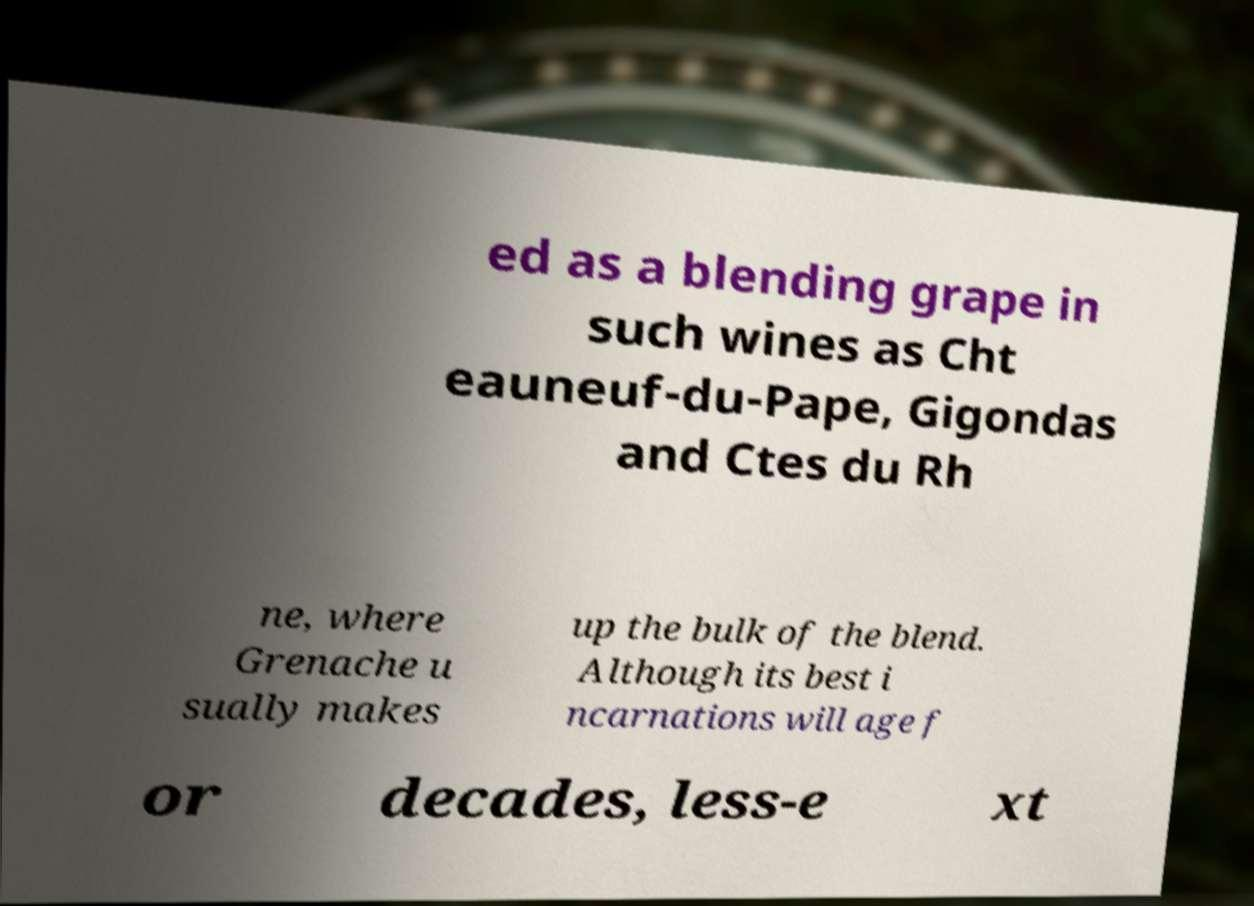Could you assist in decoding the text presented in this image and type it out clearly? ed as a blending grape in such wines as Cht eauneuf-du-Pape, Gigondas and Ctes du Rh ne, where Grenache u sually makes up the bulk of the blend. Although its best i ncarnations will age f or decades, less-e xt 